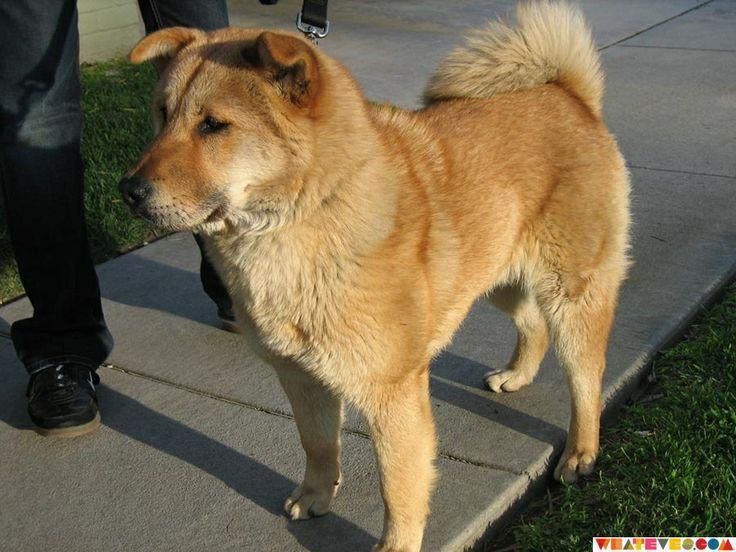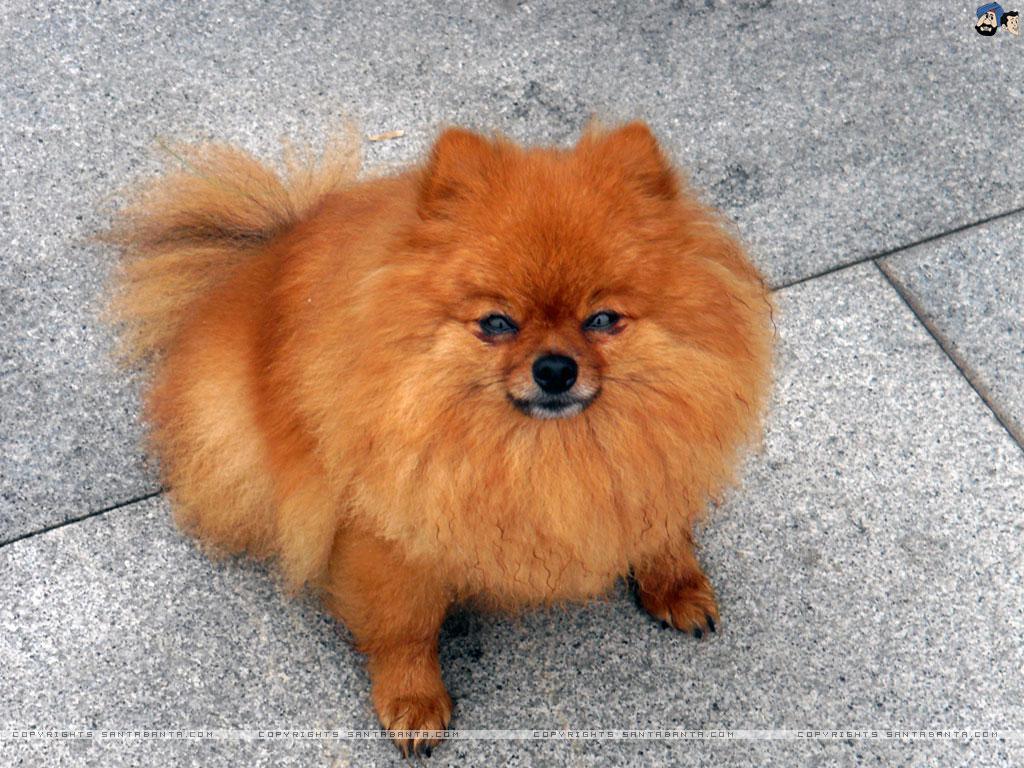The first image is the image on the left, the second image is the image on the right. Considering the images on both sides, is "The dog on the right is clearly a much smaller, shorter animal than the dog on the left." valid? Answer yes or no. Yes. 